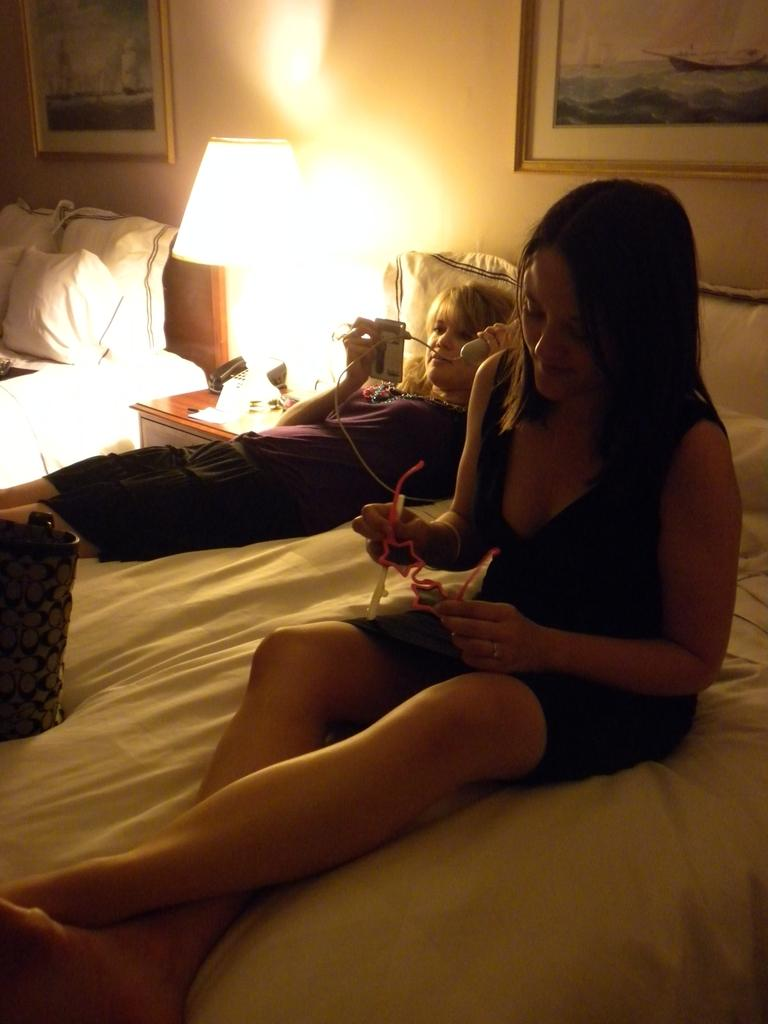What is the person in the black dress wearing in the image? The person in the black dress is wearing a black dress in the image. What is the person in the black dress doing? The person in the black dress is sitting on a bed in the image. What is the person in the black dress holding? The person in the black dress is holding pink spectacles in the image. How many people are in the image? There are two people in the image. What is the other person wearing? The other person is wearing a violet dress in the image. What is the other person doing? The other person is sleeping on the bed in the image. What is the person sleeping holding? The person sleeping is holding a phone in her hand in the image. How does the person in the black dress join the quiver in the image? There is no quiver present in the image, and the person in the black dress does not join any quiver. 